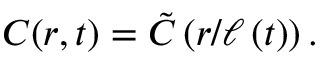<formula> <loc_0><loc_0><loc_500><loc_500>C ( r , t ) = \tilde { C } \left ( r / \ell \left ( t \right ) \right ) .</formula> 